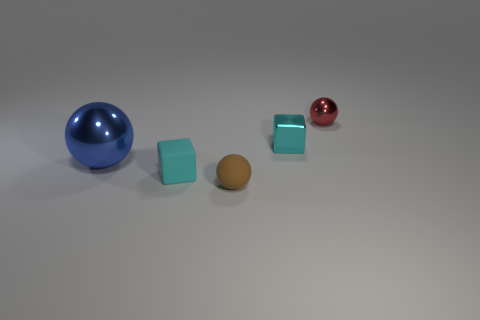Add 1 small brown rubber objects. How many objects exist? 6 Subtract all small brown spheres. Subtract all tiny cyan metallic objects. How many objects are left? 3 Add 4 brown spheres. How many brown spheres are left? 5 Add 2 small metal things. How many small metal things exist? 4 Subtract 0 cyan cylinders. How many objects are left? 5 Subtract all spheres. How many objects are left? 2 